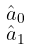Convert formula to latex. <formula><loc_0><loc_0><loc_500><loc_500>\begin{smallmatrix} \hat { a } _ { 0 } \\ \hat { a } _ { 1 } \end{smallmatrix}</formula> 